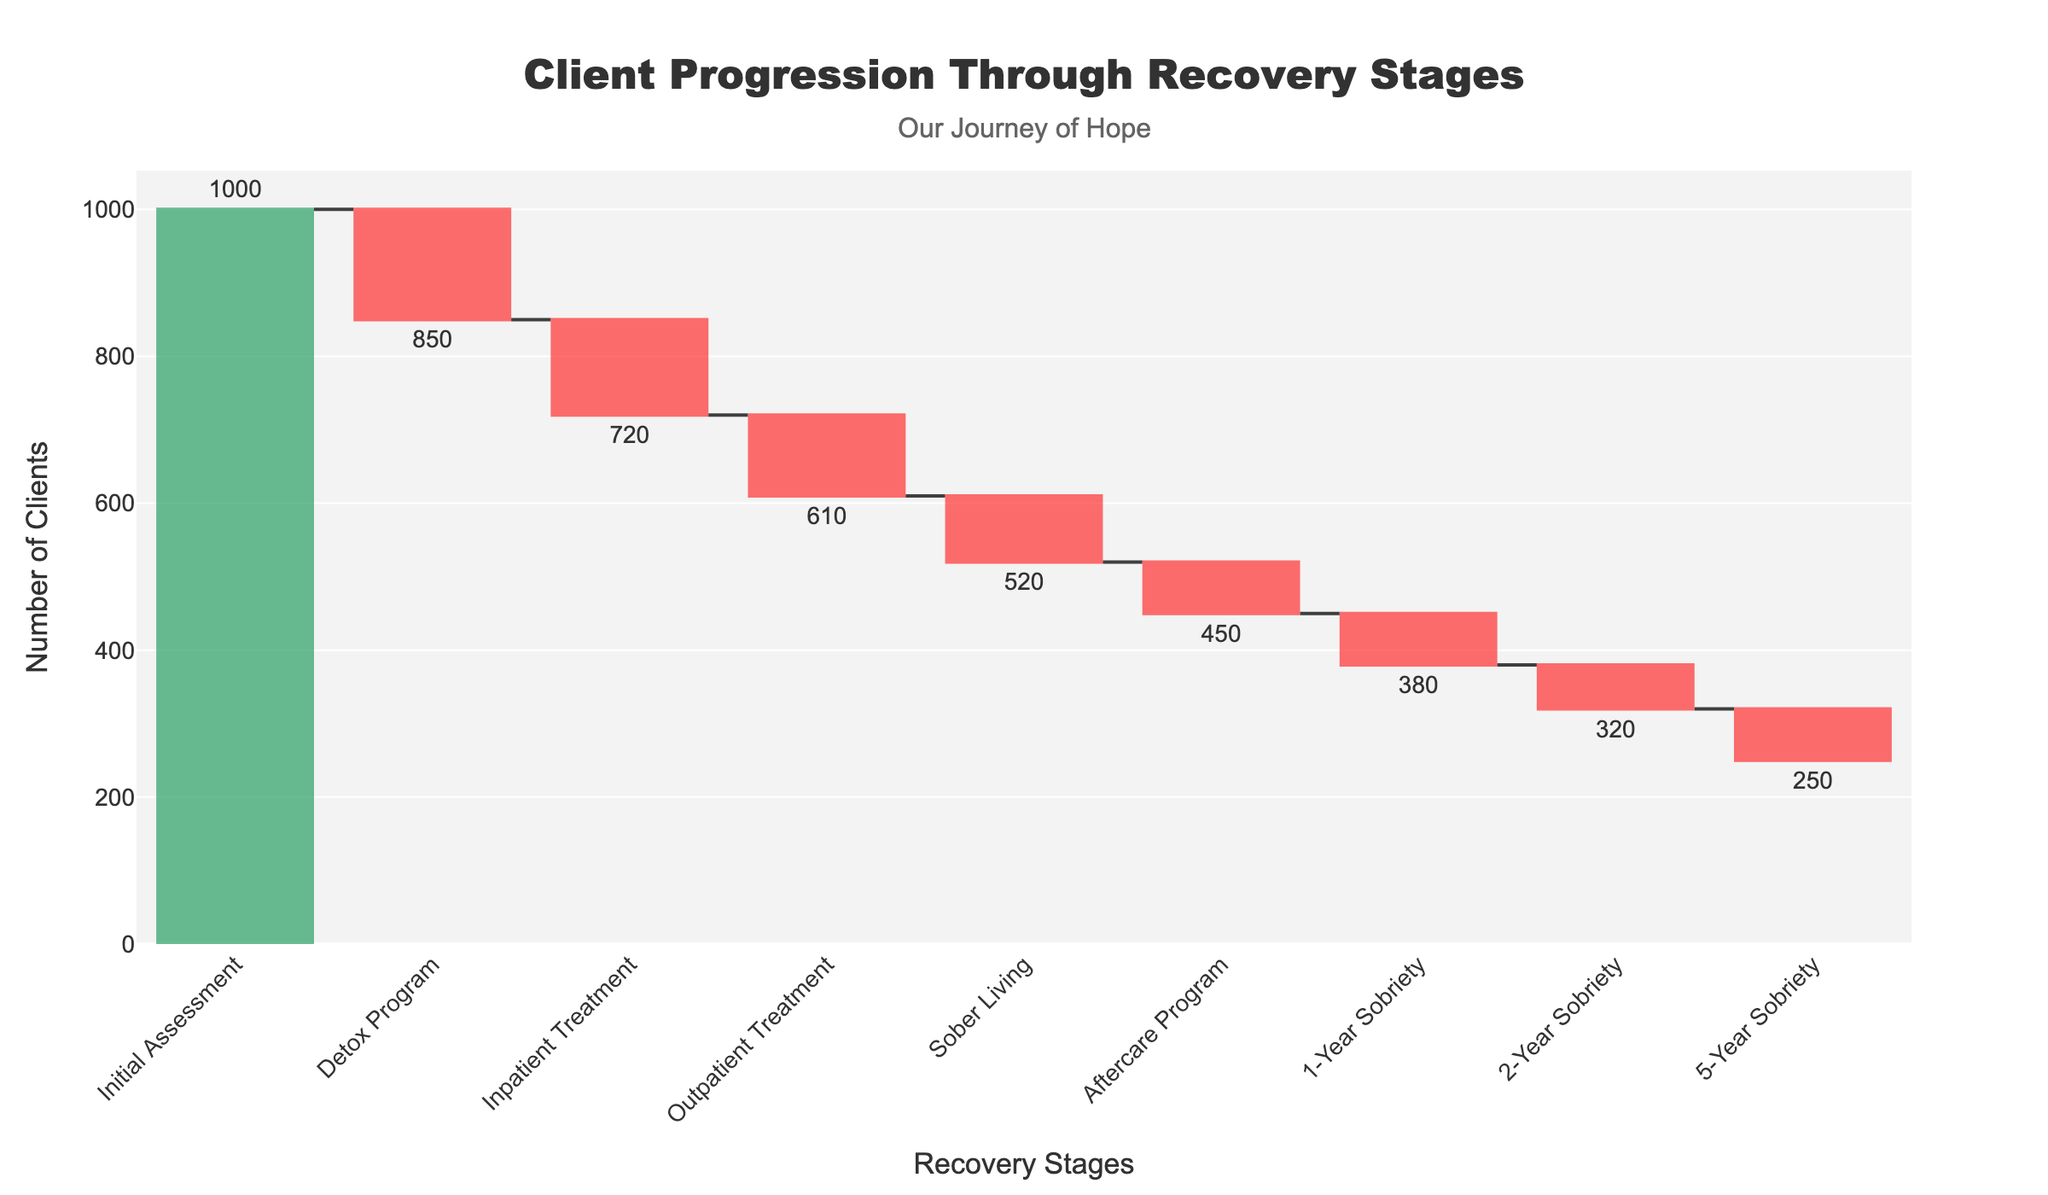How many clients started the initial assessment stage? According to the data on the waterfall chart, the initial assessment stage begins with 1000 clients
Answer: 1000 Which stage has the most significant drop in client retention? To find the stage with the most significant drop, we look at the changes in the number of clients between stages. The largest drop occurs between the initial assessment (1000 clients) and the detox program (850 clients), resulting in a drop of 150 clients
Answer: Detox Program How many clients progressed from inpatient treatment to outpatient treatment? The number of clients remaining after completing the inpatient treatment stage is 720. The number of clients then progressing to outpatient treatment is 610. This means 720 - 610 = 110 clients dropped out in this transition. Therefore, 610 clients progressed from inpatient to outpatient treatment
Answer: 610 What is the overall retention rate from the initial assessment to the 5-year sobriety stage? The retention rate can be calculated by dividing the number of clients in the 5-year sobriety stage (250) by the number initially assessed (1000), and then multiplying by 100 to get a percentage. Thus, the retention rate is (250 / 1000) * 100 = 25%
Answer: 25% By how many clients does the number of clients decrease between the outpatient treatment and sober living stages? To determine the decrease, we subtract the number of clients in the sober living stage (520) from the number in the outpatient treatment stage (610). Therefore, 610 - 520 = 90
Answer: 90 Which stages show an increase in the number of clients? In a standard recovery process for addiction, it's uncommon to see an increase in the number of clients as the process moves forward. Consequently, in this waterfall chart, there are no stages that show an increase in the number of clients; all show a decrease
Answer: None How many clients are there in the aftercare program stage? The chart indicates the aftercare program stage has 450 clients remaining
Answer: 450 Calculate the average number of clients lost between each stage. To find the average number of clients lost, we sum the differences in clients between each stage and divide by the number of transitions. These differences are: 1000-850, 850-720, 720-610, 610-520, 520-450, 450-380, 380-320, 320-250. Summing these up: 150 + 130 + 110 + 90 + 70 + 70 + 60 + 70 = 750. There are 8 transitions, so the average loss is 750 / 8 = 93.75
Answer: 93.75 Compare the retention rate between the sober living stage and the 1-year sobriety stage. The retention rate from the sober living (520 clients) to the 1-year sobriety (380 clients) is calculated by dividing the number who remain at the 1-year sobriety (380) by the number at the sober living stage (520) and multiplying by 100. That rate is (380 / 520) * 100 ≈ 73.08%
Answer: 73.08% Which stage comes directly after the detox program, and how many clients move to that stage? The inpatient treatment stage comes directly after the detox program, with 720 clients progressing to this stage
Answer: Inpatient Treatment, 720 